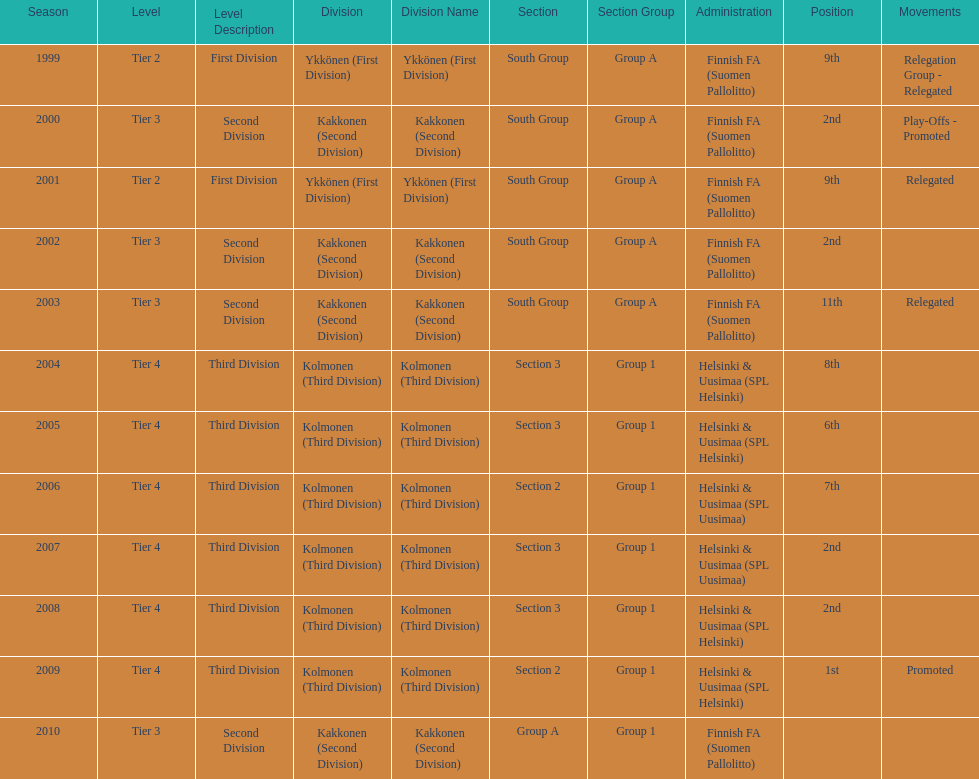What division were they in the most, section 3 or 2? 3. 